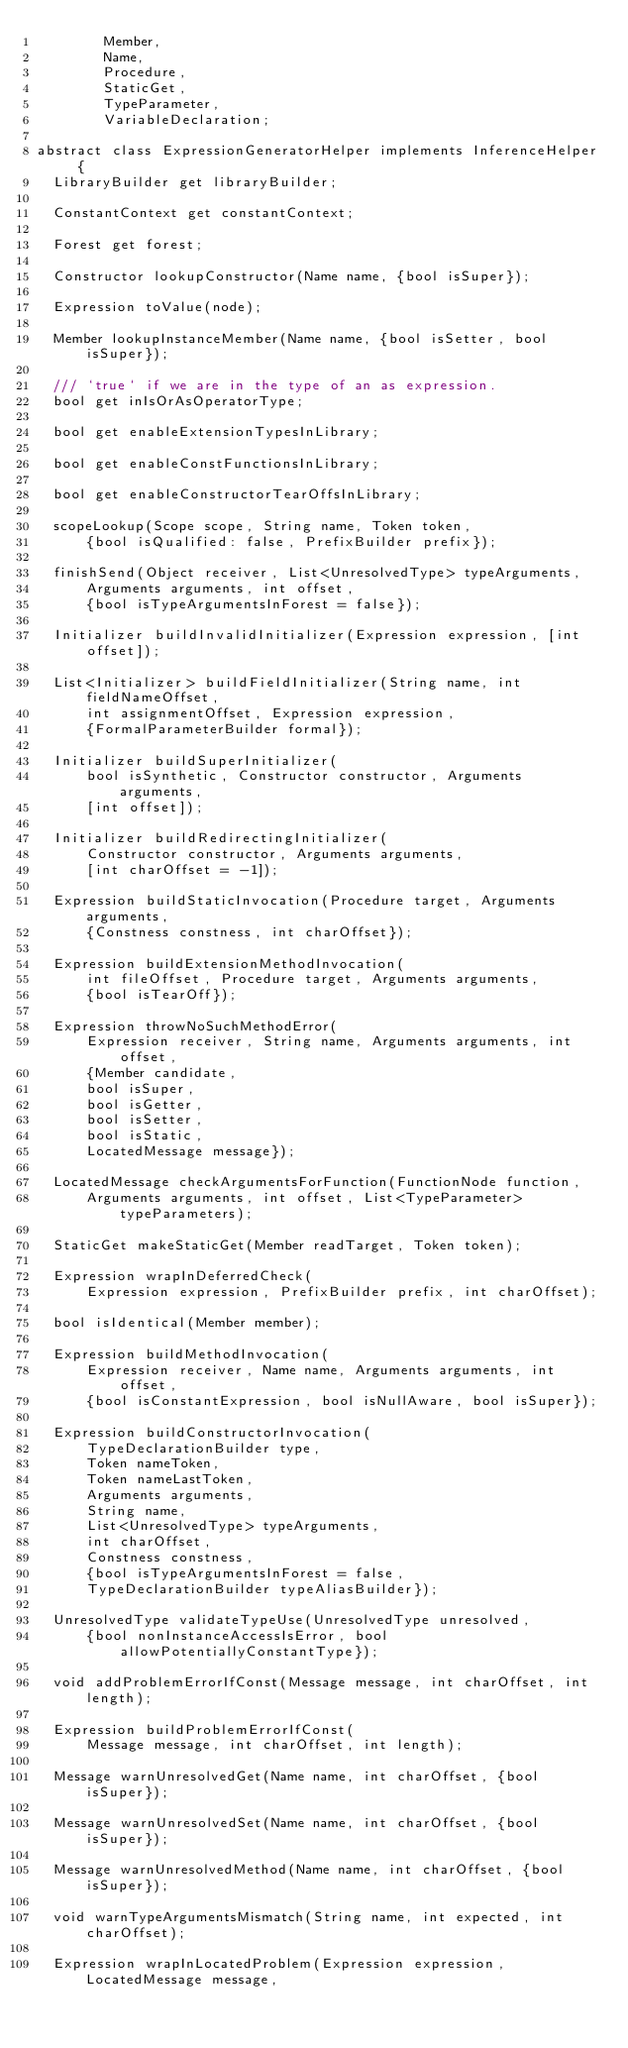Convert code to text. <code><loc_0><loc_0><loc_500><loc_500><_Dart_>        Member,
        Name,
        Procedure,
        StaticGet,
        TypeParameter,
        VariableDeclaration;

abstract class ExpressionGeneratorHelper implements InferenceHelper {
  LibraryBuilder get libraryBuilder;

  ConstantContext get constantContext;

  Forest get forest;

  Constructor lookupConstructor(Name name, {bool isSuper});

  Expression toValue(node);

  Member lookupInstanceMember(Name name, {bool isSetter, bool isSuper});

  /// `true` if we are in the type of an as expression.
  bool get inIsOrAsOperatorType;

  bool get enableExtensionTypesInLibrary;

  bool get enableConstFunctionsInLibrary;

  bool get enableConstructorTearOffsInLibrary;

  scopeLookup(Scope scope, String name, Token token,
      {bool isQualified: false, PrefixBuilder prefix});

  finishSend(Object receiver, List<UnresolvedType> typeArguments,
      Arguments arguments, int offset,
      {bool isTypeArgumentsInForest = false});

  Initializer buildInvalidInitializer(Expression expression, [int offset]);

  List<Initializer> buildFieldInitializer(String name, int fieldNameOffset,
      int assignmentOffset, Expression expression,
      {FormalParameterBuilder formal});

  Initializer buildSuperInitializer(
      bool isSynthetic, Constructor constructor, Arguments arguments,
      [int offset]);

  Initializer buildRedirectingInitializer(
      Constructor constructor, Arguments arguments,
      [int charOffset = -1]);

  Expression buildStaticInvocation(Procedure target, Arguments arguments,
      {Constness constness, int charOffset});

  Expression buildExtensionMethodInvocation(
      int fileOffset, Procedure target, Arguments arguments,
      {bool isTearOff});

  Expression throwNoSuchMethodError(
      Expression receiver, String name, Arguments arguments, int offset,
      {Member candidate,
      bool isSuper,
      bool isGetter,
      bool isSetter,
      bool isStatic,
      LocatedMessage message});

  LocatedMessage checkArgumentsForFunction(FunctionNode function,
      Arguments arguments, int offset, List<TypeParameter> typeParameters);

  StaticGet makeStaticGet(Member readTarget, Token token);

  Expression wrapInDeferredCheck(
      Expression expression, PrefixBuilder prefix, int charOffset);

  bool isIdentical(Member member);

  Expression buildMethodInvocation(
      Expression receiver, Name name, Arguments arguments, int offset,
      {bool isConstantExpression, bool isNullAware, bool isSuper});

  Expression buildConstructorInvocation(
      TypeDeclarationBuilder type,
      Token nameToken,
      Token nameLastToken,
      Arguments arguments,
      String name,
      List<UnresolvedType> typeArguments,
      int charOffset,
      Constness constness,
      {bool isTypeArgumentsInForest = false,
      TypeDeclarationBuilder typeAliasBuilder});

  UnresolvedType validateTypeUse(UnresolvedType unresolved,
      {bool nonInstanceAccessIsError, bool allowPotentiallyConstantType});

  void addProblemErrorIfConst(Message message, int charOffset, int length);

  Expression buildProblemErrorIfConst(
      Message message, int charOffset, int length);

  Message warnUnresolvedGet(Name name, int charOffset, {bool isSuper});

  Message warnUnresolvedSet(Name name, int charOffset, {bool isSuper});

  Message warnUnresolvedMethod(Name name, int charOffset, {bool isSuper});

  void warnTypeArgumentsMismatch(String name, int expected, int charOffset);

  Expression wrapInLocatedProblem(Expression expression, LocatedMessage message,</code> 